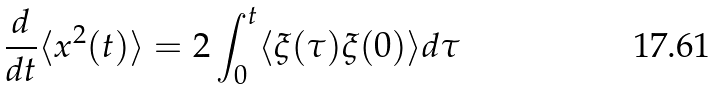Convert formula to latex. <formula><loc_0><loc_0><loc_500><loc_500>\frac { d } { d t } \langle x ^ { 2 } ( t ) \rangle = 2 \int _ { 0 } ^ { t } \langle \xi ( \tau ) \xi ( 0 ) \rangle d \tau</formula> 